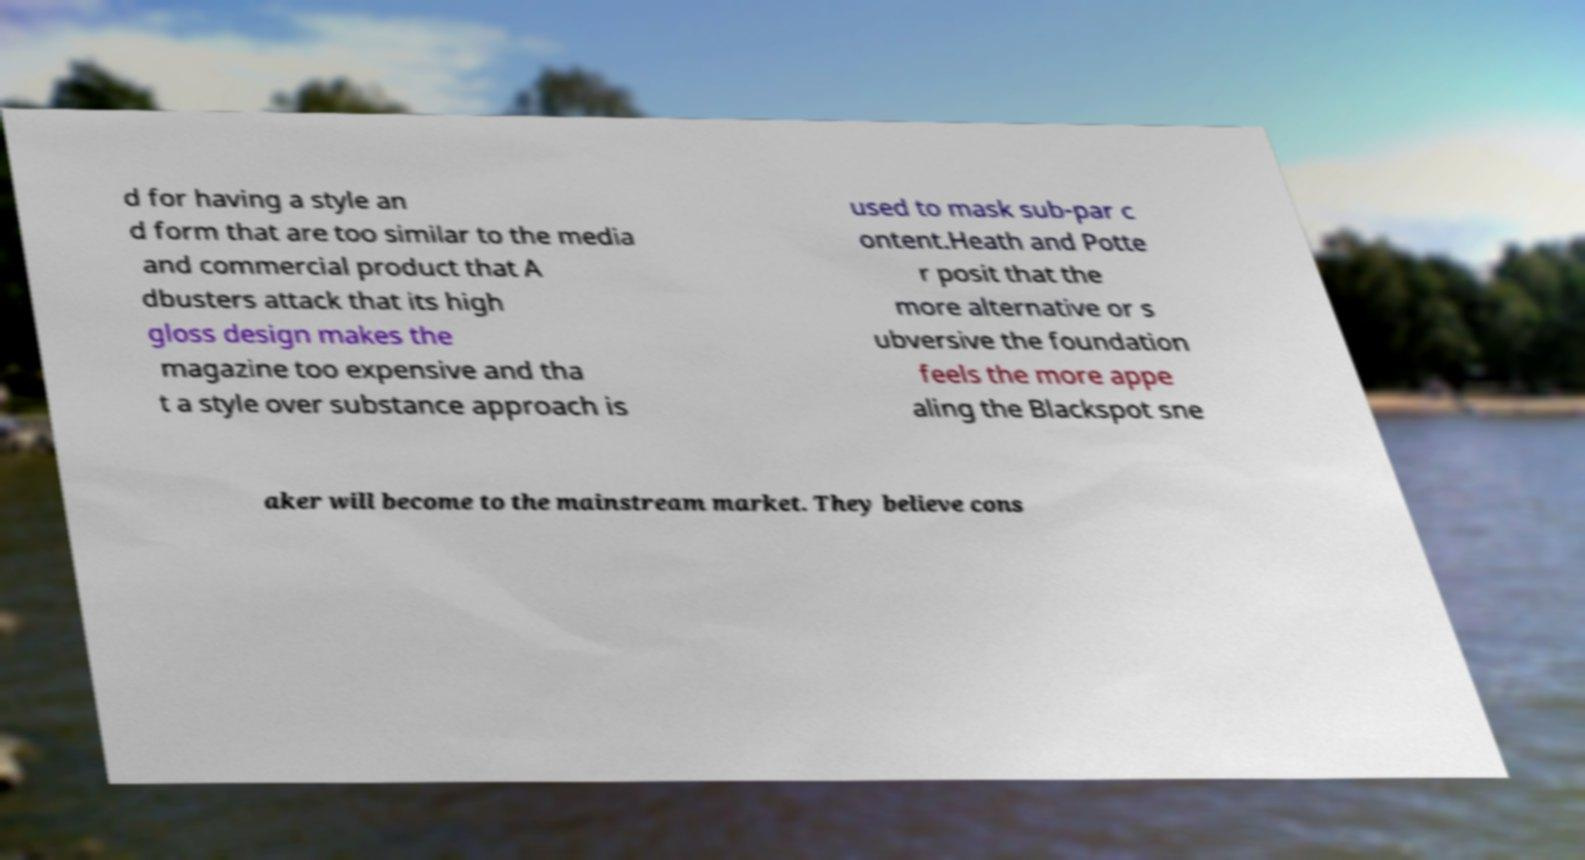Can you read and provide the text displayed in the image?This photo seems to have some interesting text. Can you extract and type it out for me? d for having a style an d form that are too similar to the media and commercial product that A dbusters attack that its high gloss design makes the magazine too expensive and tha t a style over substance approach is used to mask sub-par c ontent.Heath and Potte r posit that the more alternative or s ubversive the foundation feels the more appe aling the Blackspot sne aker will become to the mainstream market. They believe cons 